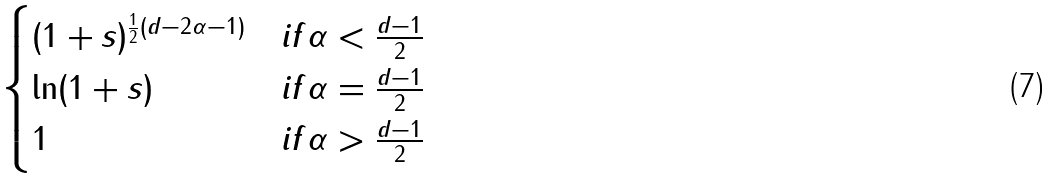Convert formula to latex. <formula><loc_0><loc_0><loc_500><loc_500>\begin{cases} ( 1 + s ) ^ { \frac { 1 } { 2 } ( d - 2 \alpha - 1 ) } & i f \alpha < \frac { d - 1 } { 2 } \\ \ln ( 1 + s ) & i f \alpha = \frac { d - 1 } { 2 } \\ 1 & i f \alpha > \frac { d - 1 } { 2 } \\ \end{cases}</formula> 